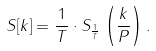Convert formula to latex. <formula><loc_0><loc_0><loc_500><loc_500>S [ k ] = { \frac { 1 } { T } } \cdot S _ { \frac { 1 } { T } } \left ( { \frac { k } { P } } \right ) .</formula> 